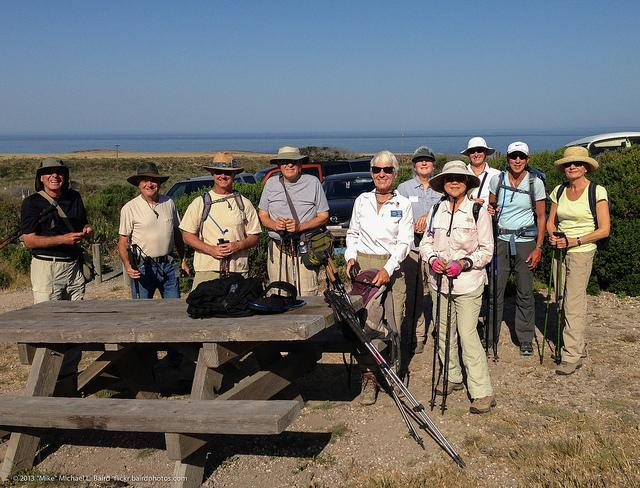What activity is this group preparing for? hiking 